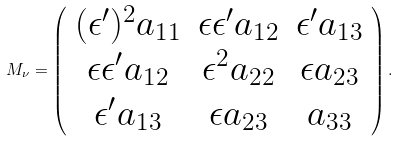<formula> <loc_0><loc_0><loc_500><loc_500>M _ { \nu } = \left ( \begin{array} { c c c } { { ( \epsilon ^ { \prime } ) ^ { 2 } a _ { 1 1 } } } & { { \epsilon \epsilon ^ { \prime } a _ { 1 2 } } } & { { \epsilon ^ { \prime } a _ { 1 3 } } } \\ { { \epsilon \epsilon ^ { \prime } a _ { 1 2 } } } & { { \epsilon ^ { 2 } a _ { 2 2 } } } & { { \epsilon a _ { 2 3 } } } \\ { { \epsilon ^ { \prime } a _ { 1 3 } } } & { { \epsilon a _ { 2 3 } } } & { { a _ { 3 3 } } } \end{array} \right ) .</formula> 